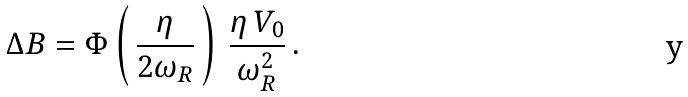Convert formula to latex. <formula><loc_0><loc_0><loc_500><loc_500>\Delta B = \Phi \left ( \, \frac { \eta } { 2 \omega _ { R } } \, \right ) \, \frac { \eta \, V _ { 0 } } { \omega _ { R } ^ { 2 } } \, .</formula> 